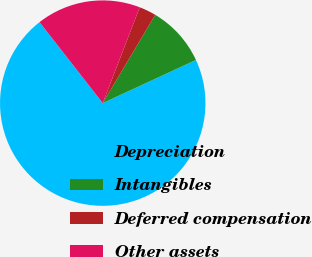Convert chart. <chart><loc_0><loc_0><loc_500><loc_500><pie_chart><fcel>Depreciation<fcel>Intangibles<fcel>Deferred compensation<fcel>Other assets<nl><fcel>71.36%<fcel>9.55%<fcel>2.68%<fcel>16.41%<nl></chart> 